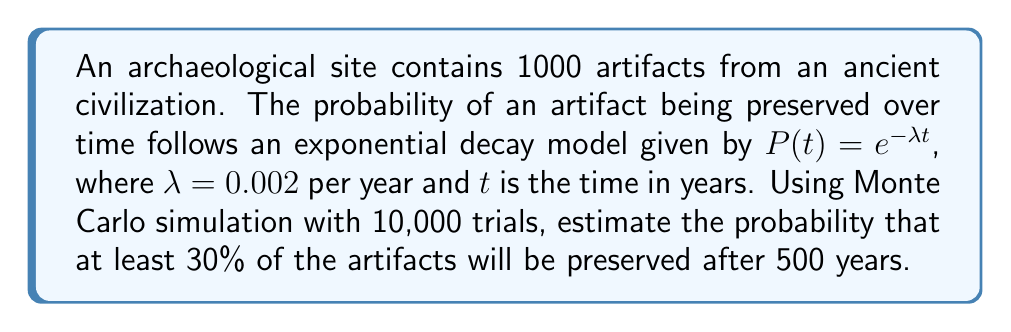Solve this math problem. To solve this problem using Monte Carlo simulation, we'll follow these steps:

1. Set up the simulation parameters:
   - Number of artifacts: $N = 1000$
   - Number of trials: $M = 10000$
   - Time: $t = 500$ years
   - Decay rate: $\lambda = 0.002$ per year
   - Threshold: $30\%$ of artifacts (300 artifacts)

2. For each trial:
   a. Generate 1000 random numbers $r_i$ uniformly distributed between 0 and 1.
   b. For each artifact, calculate if it's preserved using the condition:
      $r_i < P(t) = e^{-\lambda t} = e^{-0.002 \cdot 500} \approx 0.3679$
   c. Count the number of preserved artifacts.
   d. Check if the number of preserved artifacts is at least 300.

3. Count the number of successful trials (where at least 300 artifacts are preserved).

4. Calculate the probability by dividing the number of successful trials by the total number of trials.

Python code for the simulation:

```python
import numpy as np

N = 1000  # number of artifacts
M = 10000  # number of trials
t = 500  # time in years
lambda_ = 0.002  # decay rate
threshold = 300  # 30% of artifacts

P_t = np.exp(-lambda_ * t)
successes = 0

for _ in range(M):
    preserved = np.random.random(N) < P_t
    if np.sum(preserved) >= threshold:
        successes += 1

probability = successes / M
```

The estimated probability will vary slightly due to the random nature of Monte Carlo simulation, but it should converge to approximately 0.8465 as the number of trials increases.
Answer: $\approx 0.8465$ 